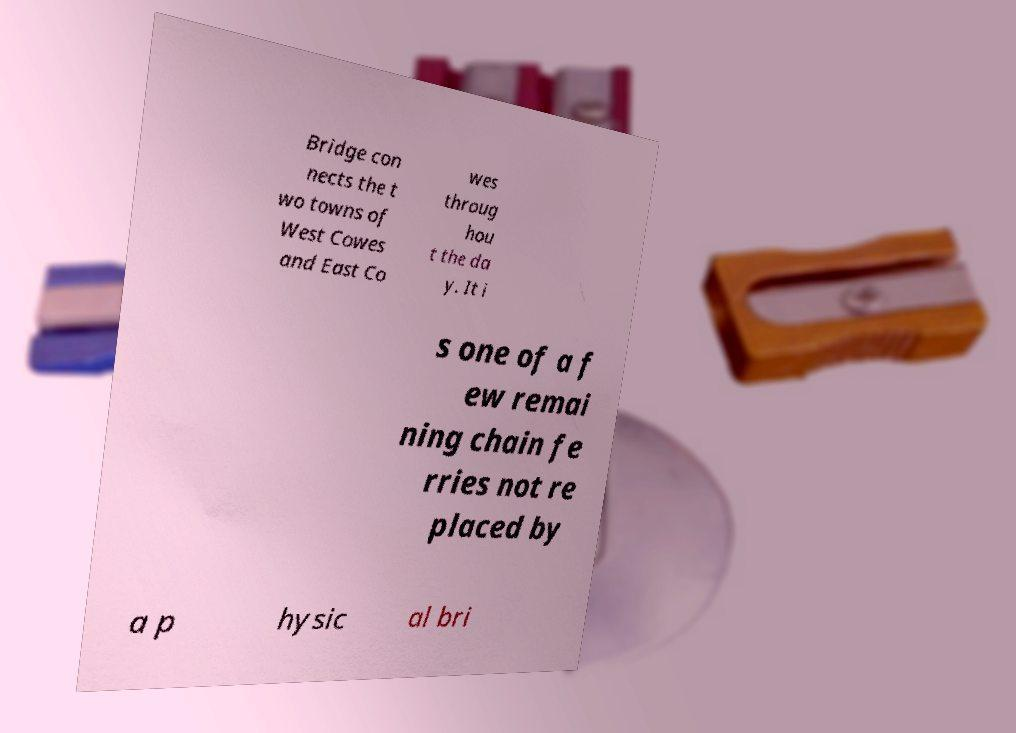Could you assist in decoding the text presented in this image and type it out clearly? Bridge con nects the t wo towns of West Cowes and East Co wes throug hou t the da y. It i s one of a f ew remai ning chain fe rries not re placed by a p hysic al bri 